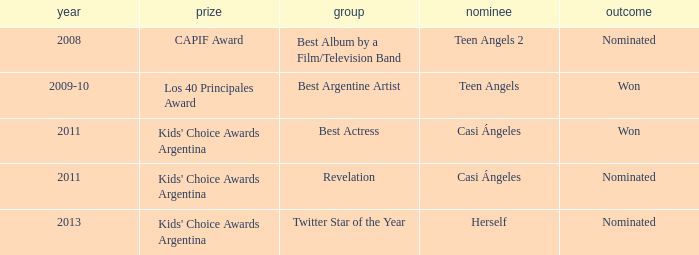What year was there a nomination for Best Actress at the Kids' Choice Awards Argentina? 2011.0. 